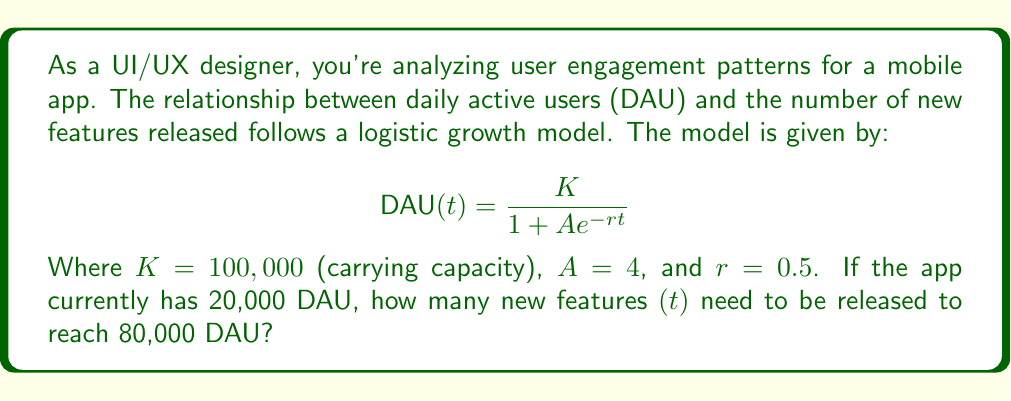Help me with this question. To solve this problem, we'll follow these steps:

1) We're given the logistic growth model:
   $$ DAU(t) = \frac{K}{1 + Ae^{-rt}} $$

2) We know:
   $K = 100,000$
   $A = 4$
   $r = 0.5$
   Current DAU = 20,000
   Target DAU = 80,000

3) Let's substitute the target DAU into the equation:
   $$ 80,000 = \frac{100,000}{1 + 4e^{-0.5t}} $$

4) Simplify:
   $$ 0.8 = \frac{1}{1 + 4e^{-0.5t}} $$

5) Take the reciprocal of both sides:
   $$ 1.25 = 1 + 4e^{-0.5t} $$

6) Subtract 1 from both sides:
   $$ 0.25 = 4e^{-0.5t} $$

7) Divide both sides by 4:
   $$ 0.0625 = e^{-0.5t} $$

8) Take the natural log of both sides:
   $$ \ln(0.0625) = -0.5t $$

9) Solve for t:
   $$ t = \frac{-\ln(0.0625)}{0.5} = \frac{2.77259}{0.5} = 5.54518 $$

Therefore, approximately 6 new features need to be released to reach 80,000 DAU.
Answer: 6 new features 